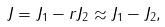<formula> <loc_0><loc_0><loc_500><loc_500>J = J _ { 1 } - r J _ { 2 } \approx J _ { 1 } - J _ { 2 } ,</formula> 